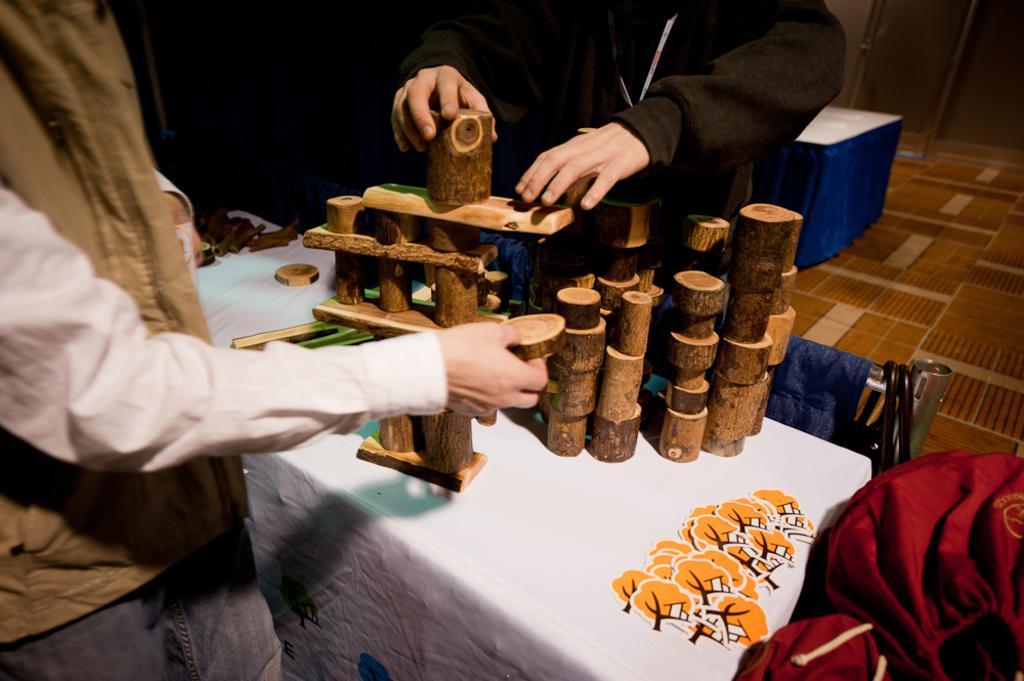Could you give a brief overview of what you see in this image? In this image there are two persons arranging wooden blocks one above the other on the table. 